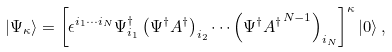Convert formula to latex. <formula><loc_0><loc_0><loc_500><loc_500>| \Psi _ { \kappa } \rangle = \left [ \epsilon ^ { i _ { 1 } \cdots i _ { N } } \Psi _ { i _ { 1 } } ^ { \dagger } \left ( \Psi ^ { \dagger } A ^ { \dagger } \right ) _ { i _ { 2 } } \cdots \left ( \Psi ^ { \dagger } { A ^ { \dagger } } ^ { N - 1 } \right ) _ { i _ { N } } \right ] ^ { \kappa } | 0 \rangle \, ,</formula> 